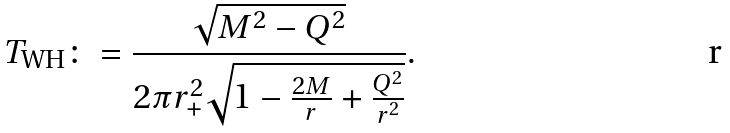Convert formula to latex. <formula><loc_0><loc_0><loc_500><loc_500>T _ { \text {WH} } \colon = \frac { \sqrt { M ^ { 2 } - Q ^ { 2 } } } { 2 \pi r _ { + } ^ { 2 } \sqrt { 1 - \frac { 2 M } { r } + \frac { Q ^ { 2 } } { r ^ { 2 } } } } .</formula> 